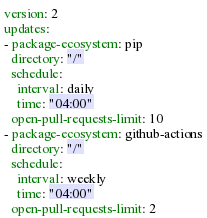<code> <loc_0><loc_0><loc_500><loc_500><_YAML_>version: 2
updates:
- package-ecosystem: pip
  directory: "/"
  schedule:
    interval: daily
    time: "04:00"
  open-pull-requests-limit: 10
- package-ecosystem: github-actions
  directory: "/"
  schedule:
    interval: weekly
    time: "04:00"
  open-pull-requests-limit: 2
</code> 